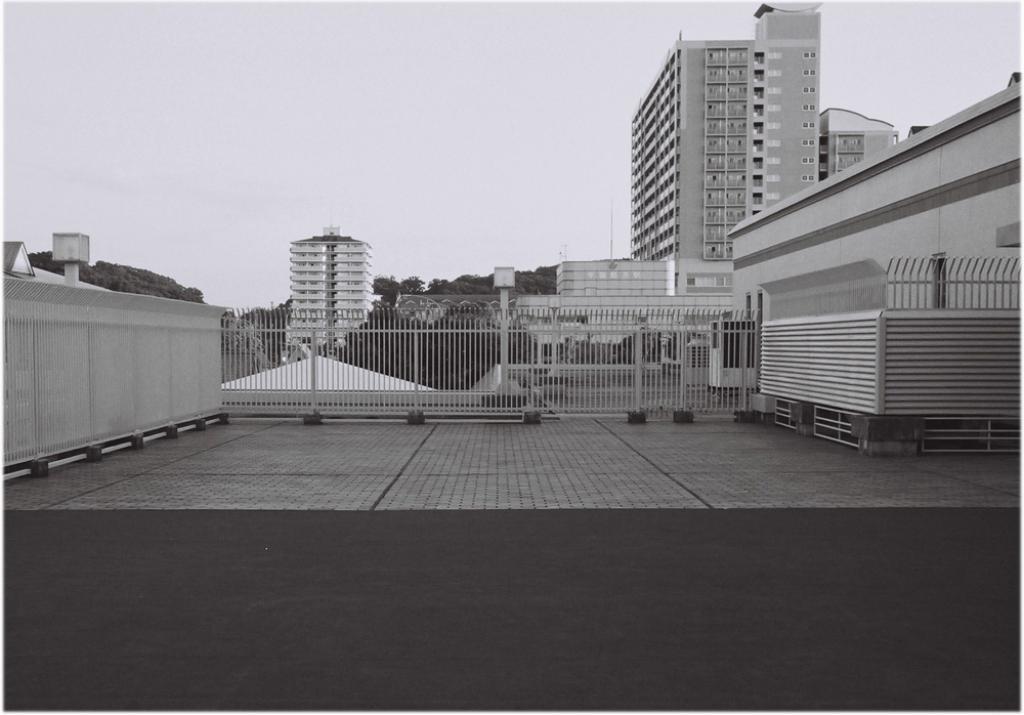Please provide a concise description of this image. This is a black and white picture, in this image we can see a few buildings, there are some trees, windows, fence, poles and lights, also we can see the sky. 